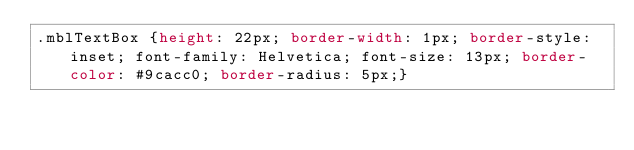<code> <loc_0><loc_0><loc_500><loc_500><_CSS_>.mblTextBox {height: 22px; border-width: 1px; border-style: inset; font-family: Helvetica; font-size: 13px; border-color: #9cacc0; border-radius: 5px;}</code> 